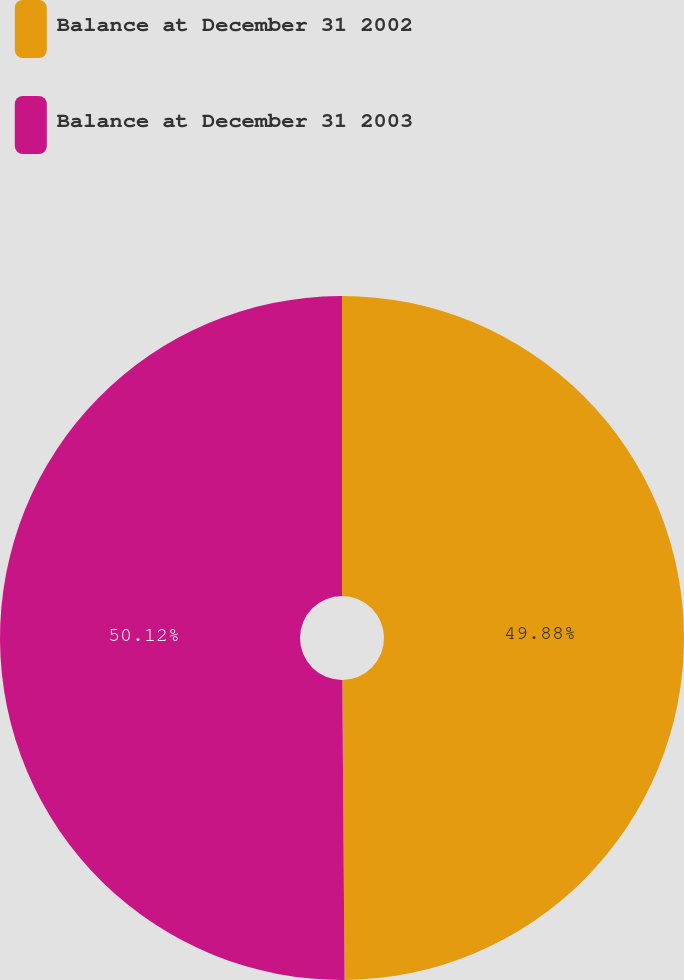Convert chart. <chart><loc_0><loc_0><loc_500><loc_500><pie_chart><fcel>Balance at December 31 2002<fcel>Balance at December 31 2003<nl><fcel>49.88%<fcel>50.12%<nl></chart> 